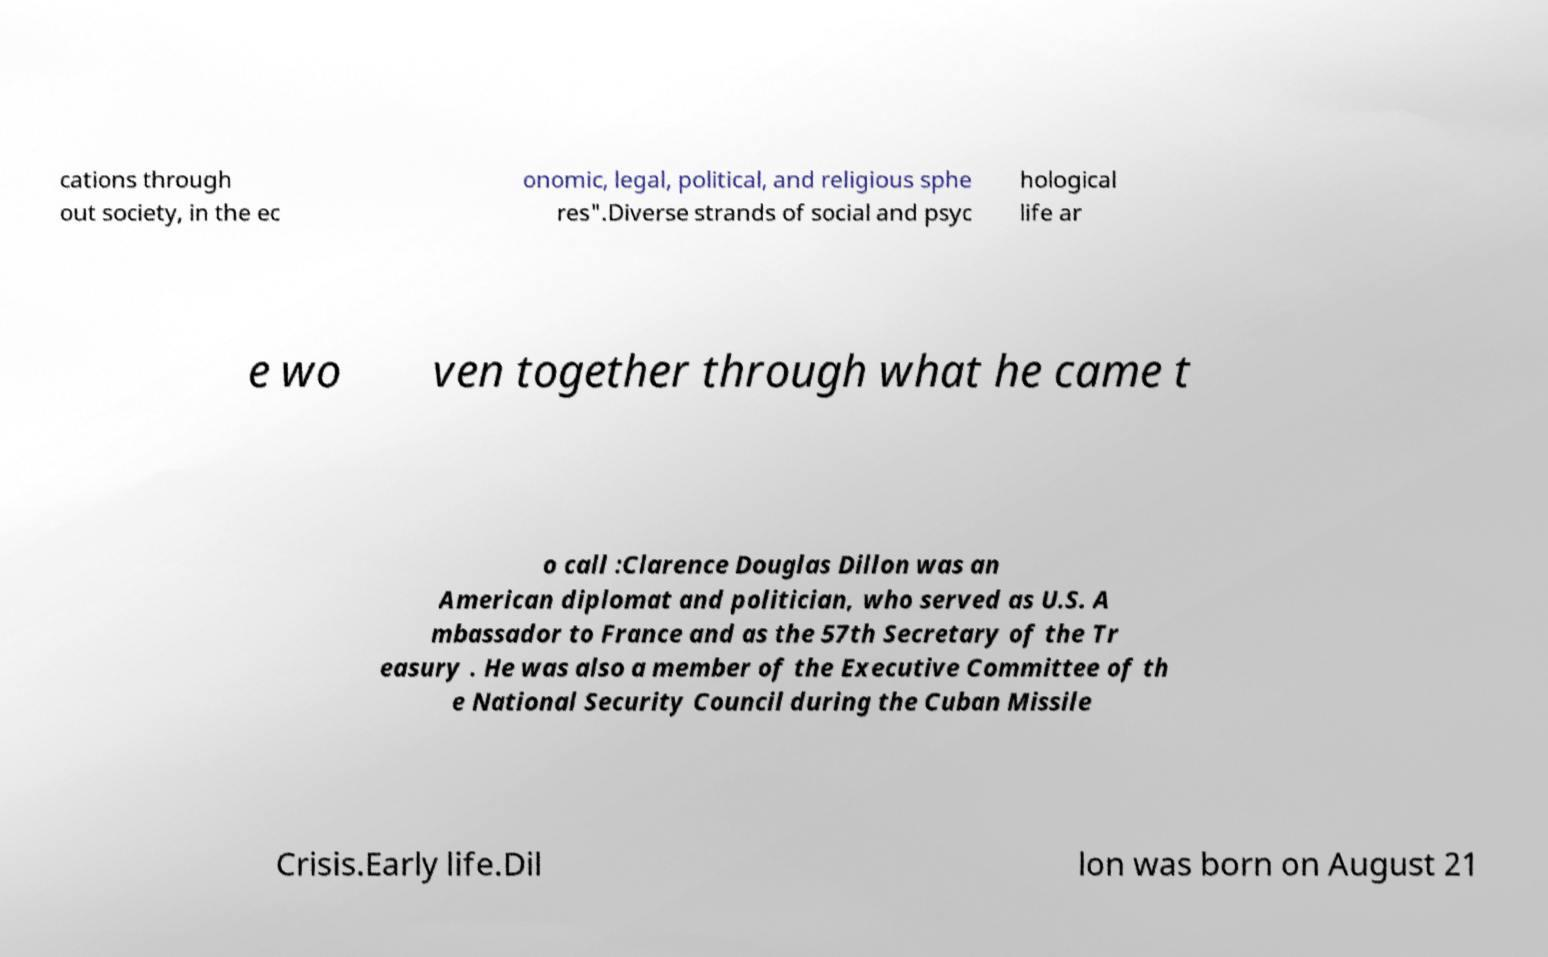For documentation purposes, I need the text within this image transcribed. Could you provide that? cations through out society, in the ec onomic, legal, political, and religious sphe res".Diverse strands of social and psyc hological life ar e wo ven together through what he came t o call :Clarence Douglas Dillon was an American diplomat and politician, who served as U.S. A mbassador to France and as the 57th Secretary of the Tr easury . He was also a member of the Executive Committee of th e National Security Council during the Cuban Missile Crisis.Early life.Dil lon was born on August 21 